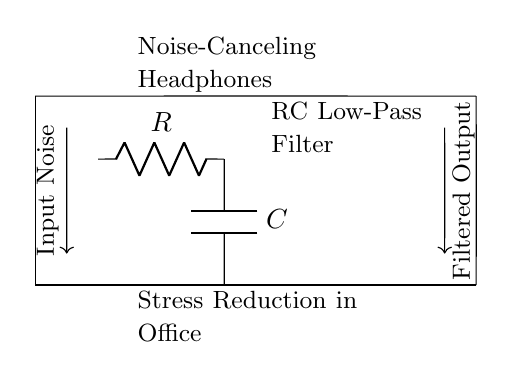What type of filter is represented in the circuit? The circuit diagram depicts an RC low-pass filter, which is identified by the presence of a resistor and capacitor arranged to allow low-frequency signals to pass through while attenuating high-frequency signals.
Answer: RC low-pass filter What components are used in the filter? The circuit diagram contains a resistor and a capacitor, which are the two essential components that define the behavior of the low-pass filter by controlling the passing of different frequency signals.
Answer: Resistor and capacitor What does the input noise represent in the context of this circuit? The input noise refers to unwanted sound signals or disturbances that the noise-canceling headphones aim to filter out, allowing only the desired audio or ambient sounds to be heard clearly, contributing to stress reduction in work environments.
Answer: Unwanted sound signals What is the purpose of the filtered output in the circuit? The filtered output serves to provide a cleaner sound signal from which unwanted noise has been reduced, thus enhancing the listening experience by minimizing distractions and stress in the office environment.
Answer: Cleaner sound signal How does the capacitor affect the circuit's response to high frequencies? In this circuit, the capacitor blocks high-frequency signals while allowing low-frequency signals to pass, due to its charging and discharging behavior, which is integral to the operation of the low-pass filter, contributing to stress reduction by minimizing unwanted noise.
Answer: Blocks high frequencies What happens to the signal as it passes through the filter? As the signal passes through the RC low-pass filter, its high-frequency components are attenuated more than the low-frequency components, resulting in a smoother, more consistent audio output that is less likely to cause stress or distraction in the workplace.
Answer: Attenuates high frequencies What is the relationship between the resistor and capacitor's values in determining the filter's cutoff frequency? The cutoff frequency of the filter is determined by both the resistor and capacitor values, calculated using the formula f_c = 1 / (2πRC), illustrating how varying either the resistance or capacitance will affect the frequency range that is allowed to pass through, directly influencing the effectiveness of noise cancellation.
Answer: Cutoff frequency 